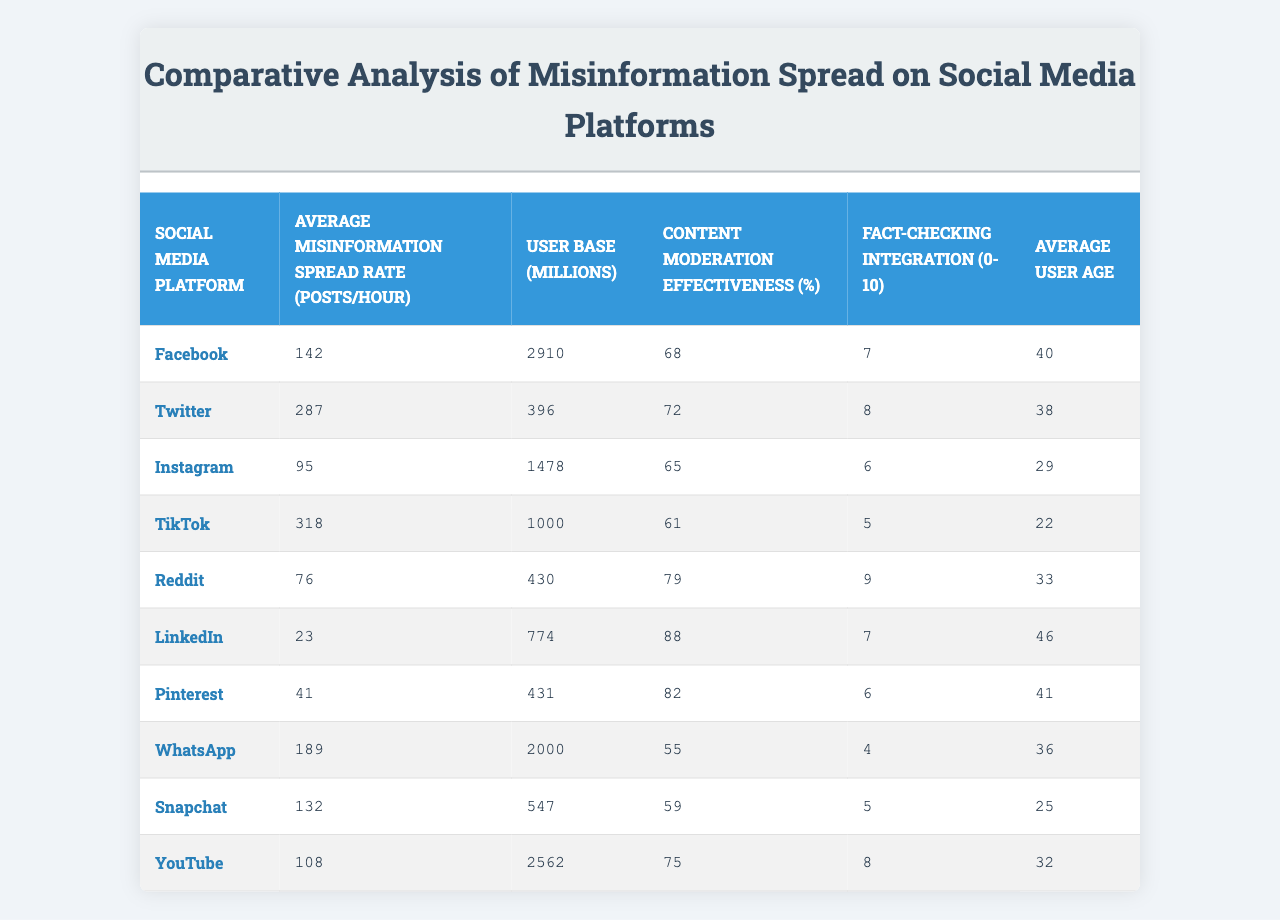What is the average misinformation spread rate on Twitter? The table shows that the average misinformation spread rate on Twitter is specifically stated in the relevant row; it is 287 posts/hour.
Answer: 287 Which social media platform has the highest content moderation effectiveness? By comparing the values in the 'Content Moderation Effectiveness (%)' column, LinkedIn has the highest effectiveness at 88%.
Answer: LinkedIn What is the average user age on Instagram? The average user age listed for Instagram in the table is 29 years.
Answer: 29 What is the total user base (in millions) for all platforms listed? To find the total user base, sum all the user base values: (2910 + 396 + 1478 + 1000 + 430 + 774 + 431 + 2000 + 547 + 2562) = 10349 million.
Answer: 10349 million Is TikTok's misinformation spread rate higher than Facebook's? Comparing the misinformation spread rates, TikTok's rate is 318, while Facebook's rate is 142. Since 318 is greater than 142, the statement is true.
Answer: Yes Which platform has the lowest average misinformation spread rate, and what is that rate? By inspecting the 'Average Misinformation Spread Rate (posts/hour)' column, Reddit has the lowest rate at 76 posts/hour.
Answer: Reddit, 76 What is the difference in average misinformation spread rate between TikTok and LinkedIn? Calculate the difference between TikTok's rate (318) and LinkedIn's rate (23): 318 - 23 = 295.
Answer: 295 How does WhatsApp's content moderation effectiveness compare to TikTok's? WhatsApp has a content moderation effectiveness of 55%, while TikTok has 61%. Since 55 is less than 61, WhatsApp is less effective than TikTok.
Answer: Less effective Which platform has both the highest average misinformation spread rate and the youngest average user age? Analyze both the average misinformation spread rates and average user ages; TikTok has the highest spread rate (318) and the youngest user age (22). Thus, TikTok meets both criteria.
Answer: TikTok What is the relationship between user base size and misinformation spread rate for the platforms listed? By examining the two columns, larger platforms tend to have higher misinformation spread rates, particularly TikTok and Twitter, suggesting a positive correlation.
Answer: Positive correlation 